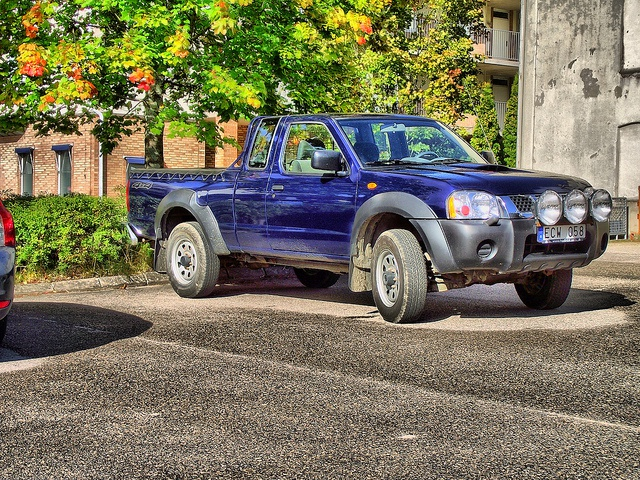Describe the objects in this image and their specific colors. I can see truck in tan, black, gray, navy, and darkgray tones and car in tan, black, gray, and maroon tones in this image. 